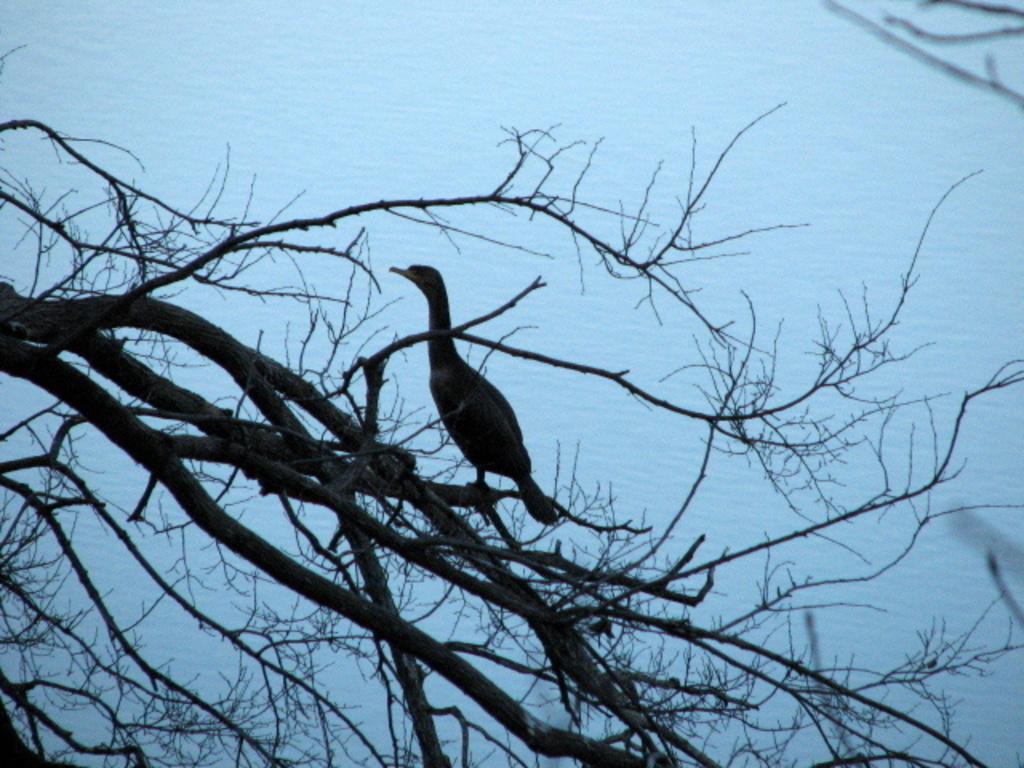Can you describe this image briefly? In this image in the middle, there is a bird. At the bottom there are trees. In the background there is water. 